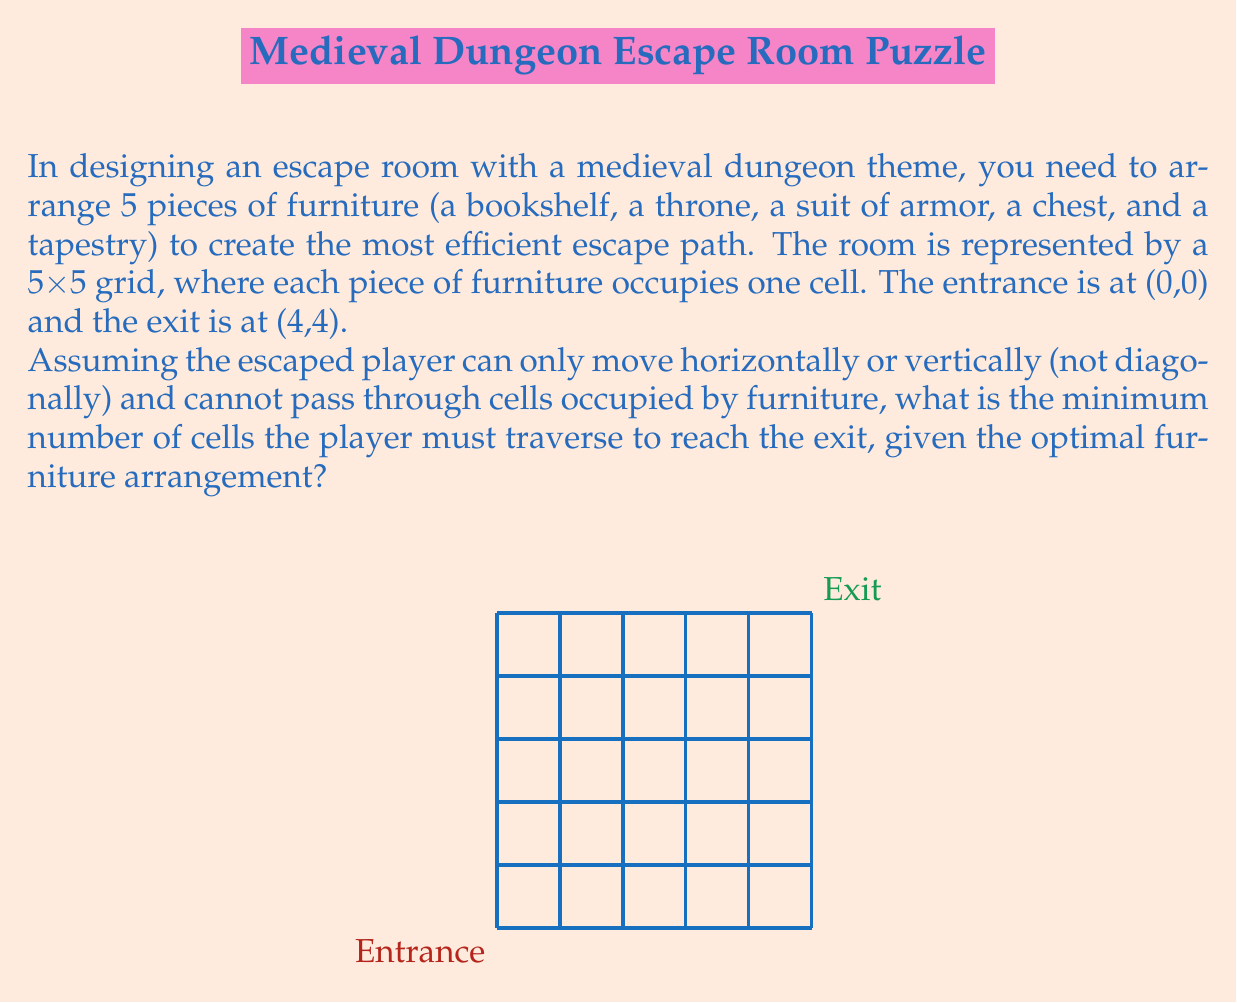Help me with this question. To solve this optimization problem, we need to follow these steps:

1) First, we need to understand that the most efficient path will always be a straight line from the entrance to the exit, if possible. This would be the diagonal from (0,0) to (4,4).

2) However, since the player can only move horizontally or vertically, the shortest possible path without any obstacles would be 8 moves: 4 right and 4 up in any order.

3) Now, we need to place the furniture in a way that minimally interferes with this path. The optimal arrangement would be to place all furniture pieces away from this shortest path.

4) Given that we have 5 pieces of furniture and a 5x5 grid, we can place all furniture off the shortest path. Here's one optimal arrangement:

   [asy]
   unitsize(1cm);
   for(int i=0; i<5; ++i) {
     for(int j=0; j<5; ++j) {
       draw((i,j)--(i+1,j)--(i+1,j+1)--(i,j+1)--cycle);
     }
   }
   label("E", (0.5,0.5));
   label("X", (4.5,4.5));
   label("B", (0.5,4.5));
   label("T", (1.5,3.5));
   label("A", (2.5,2.5));
   label("C", (3.5,1.5));
   label("P", (4.5,0.5));
   draw((0,0)--(5,5),dashed);
   [/asy]

   Where E is the entrance, X is the exit, and B, T, A, C, P represent the bookshelf, throne, armor, chest, and tapestry respectively.

5) With this arrangement, the player can follow the shortest path from (0,0) to (4,4) without any obstructions.

6) Therefore, the minimum number of cells the player must traverse is 8: 4 moves right and 4 moves up.
Answer: 8 cells 